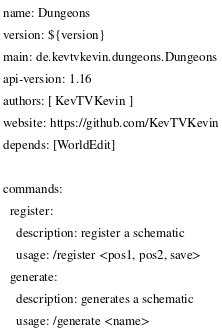Convert code to text. <code><loc_0><loc_0><loc_500><loc_500><_YAML_>name: Dungeons
version: ${version}
main: de.kevtvkevin.dungeons.Dungeons
api-version: 1.16
authors: [ KevTVKevin ]
website: https://github.com/KevTVKevin
depends: [WorldEdit]

commands:
  register:
    description: register a schematic
    usage: /register <pos1, pos2, save>
  generate:
    description: generates a schematic
    usage: /generate <name></code> 